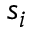Convert formula to latex. <formula><loc_0><loc_0><loc_500><loc_500>s _ { i }</formula> 